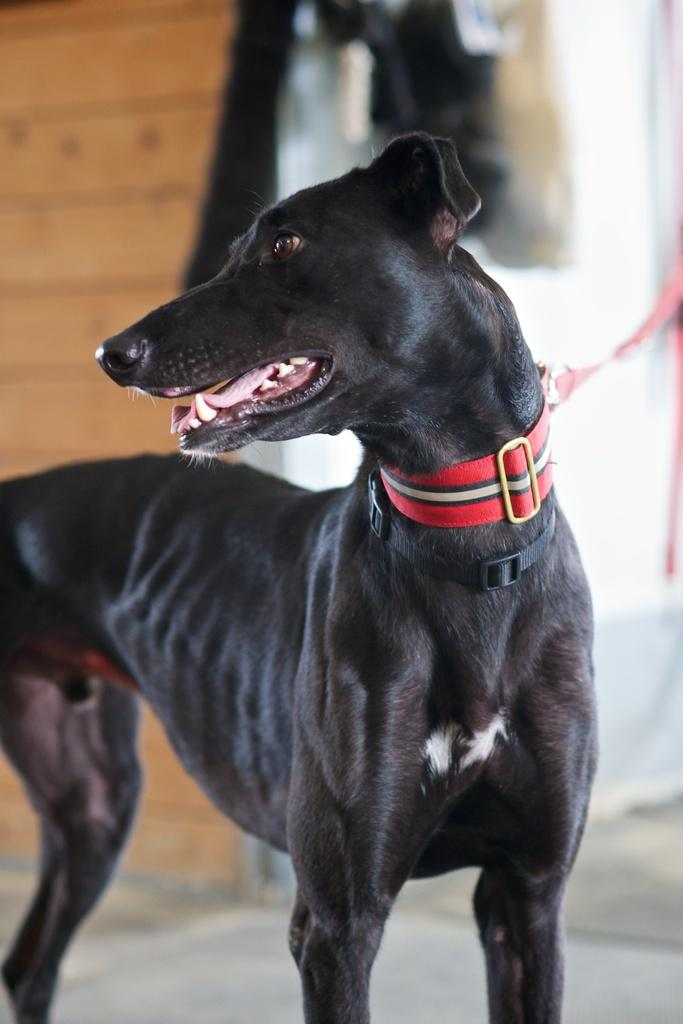What is on the floor in the image? There is a dog on the floor in the image. Can you describe the person in the background of the image? The person is in the background of the image, on the steps. What can be inferred about the time of day when the image was taken? The image was likely taken during the day, as no mention of night or darkness is made. How many plastic buckets are visible in the image? There are no plastic buckets present in the image. What type of lizards can be seen crawling on the dog in the image? There are no lizards present in the image, and the dog is not interacting with any lizards. 